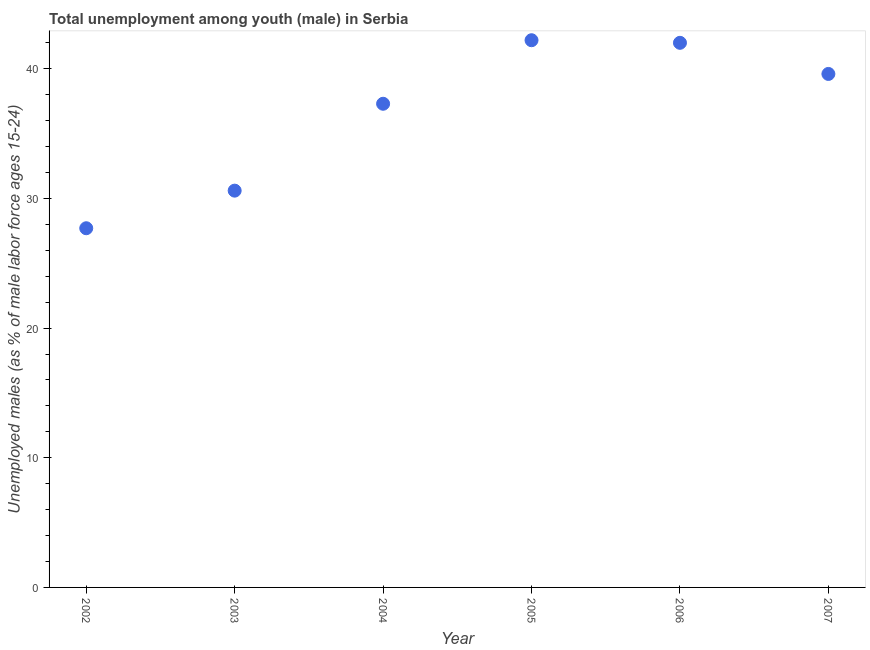What is the unemployed male youth population in 2002?
Provide a succinct answer. 27.7. Across all years, what is the maximum unemployed male youth population?
Offer a very short reply. 42.2. Across all years, what is the minimum unemployed male youth population?
Offer a terse response. 27.7. In which year was the unemployed male youth population minimum?
Offer a terse response. 2002. What is the sum of the unemployed male youth population?
Give a very brief answer. 219.4. What is the difference between the unemployed male youth population in 2003 and 2005?
Make the answer very short. -11.6. What is the average unemployed male youth population per year?
Give a very brief answer. 36.57. What is the median unemployed male youth population?
Your answer should be very brief. 38.45. Do a majority of the years between 2002 and 2006 (inclusive) have unemployed male youth population greater than 34 %?
Offer a terse response. Yes. What is the ratio of the unemployed male youth population in 2003 to that in 2007?
Make the answer very short. 0.77. Is the difference between the unemployed male youth population in 2002 and 2007 greater than the difference between any two years?
Ensure brevity in your answer.  No. What is the difference between the highest and the second highest unemployed male youth population?
Ensure brevity in your answer.  0.2. Is the sum of the unemployed male youth population in 2004 and 2007 greater than the maximum unemployed male youth population across all years?
Offer a very short reply. Yes. What is the difference between the highest and the lowest unemployed male youth population?
Your answer should be very brief. 14.5. Does the unemployed male youth population monotonically increase over the years?
Make the answer very short. No. How many dotlines are there?
Your response must be concise. 1. Does the graph contain grids?
Your answer should be very brief. No. What is the title of the graph?
Provide a short and direct response. Total unemployment among youth (male) in Serbia. What is the label or title of the Y-axis?
Provide a succinct answer. Unemployed males (as % of male labor force ages 15-24). What is the Unemployed males (as % of male labor force ages 15-24) in 2002?
Your response must be concise. 27.7. What is the Unemployed males (as % of male labor force ages 15-24) in 2003?
Provide a succinct answer. 30.6. What is the Unemployed males (as % of male labor force ages 15-24) in 2004?
Provide a short and direct response. 37.3. What is the Unemployed males (as % of male labor force ages 15-24) in 2005?
Ensure brevity in your answer.  42.2. What is the Unemployed males (as % of male labor force ages 15-24) in 2007?
Make the answer very short. 39.6. What is the difference between the Unemployed males (as % of male labor force ages 15-24) in 2002 and 2003?
Your answer should be very brief. -2.9. What is the difference between the Unemployed males (as % of male labor force ages 15-24) in 2002 and 2006?
Your answer should be very brief. -14.3. What is the difference between the Unemployed males (as % of male labor force ages 15-24) in 2002 and 2007?
Keep it short and to the point. -11.9. What is the difference between the Unemployed males (as % of male labor force ages 15-24) in 2003 and 2004?
Give a very brief answer. -6.7. What is the difference between the Unemployed males (as % of male labor force ages 15-24) in 2003 and 2005?
Keep it short and to the point. -11.6. What is the difference between the Unemployed males (as % of male labor force ages 15-24) in 2004 and 2006?
Provide a short and direct response. -4.7. What is the difference between the Unemployed males (as % of male labor force ages 15-24) in 2004 and 2007?
Make the answer very short. -2.3. What is the difference between the Unemployed males (as % of male labor force ages 15-24) in 2005 and 2006?
Give a very brief answer. 0.2. What is the difference between the Unemployed males (as % of male labor force ages 15-24) in 2005 and 2007?
Offer a very short reply. 2.6. What is the ratio of the Unemployed males (as % of male labor force ages 15-24) in 2002 to that in 2003?
Your answer should be very brief. 0.91. What is the ratio of the Unemployed males (as % of male labor force ages 15-24) in 2002 to that in 2004?
Offer a very short reply. 0.74. What is the ratio of the Unemployed males (as % of male labor force ages 15-24) in 2002 to that in 2005?
Your answer should be very brief. 0.66. What is the ratio of the Unemployed males (as % of male labor force ages 15-24) in 2002 to that in 2006?
Give a very brief answer. 0.66. What is the ratio of the Unemployed males (as % of male labor force ages 15-24) in 2002 to that in 2007?
Your answer should be compact. 0.7. What is the ratio of the Unemployed males (as % of male labor force ages 15-24) in 2003 to that in 2004?
Your answer should be compact. 0.82. What is the ratio of the Unemployed males (as % of male labor force ages 15-24) in 2003 to that in 2005?
Your response must be concise. 0.72. What is the ratio of the Unemployed males (as % of male labor force ages 15-24) in 2003 to that in 2006?
Your answer should be very brief. 0.73. What is the ratio of the Unemployed males (as % of male labor force ages 15-24) in 2003 to that in 2007?
Provide a short and direct response. 0.77. What is the ratio of the Unemployed males (as % of male labor force ages 15-24) in 2004 to that in 2005?
Offer a very short reply. 0.88. What is the ratio of the Unemployed males (as % of male labor force ages 15-24) in 2004 to that in 2006?
Keep it short and to the point. 0.89. What is the ratio of the Unemployed males (as % of male labor force ages 15-24) in 2004 to that in 2007?
Provide a succinct answer. 0.94. What is the ratio of the Unemployed males (as % of male labor force ages 15-24) in 2005 to that in 2006?
Provide a succinct answer. 1. What is the ratio of the Unemployed males (as % of male labor force ages 15-24) in 2005 to that in 2007?
Your answer should be very brief. 1.07. What is the ratio of the Unemployed males (as % of male labor force ages 15-24) in 2006 to that in 2007?
Keep it short and to the point. 1.06. 